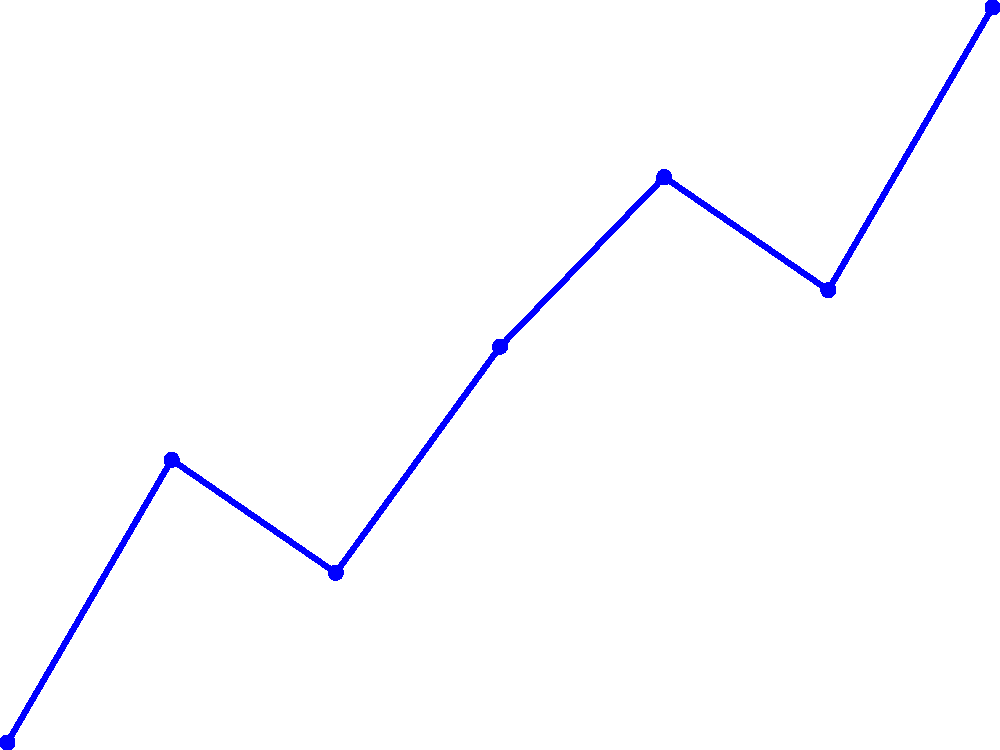Analyze the line graph showing patient medication adherence trends over seven months. What is the overall trend in adherence from January to July, and what is the difference between the highest and lowest adherence percentages? To answer this question, let's follow these steps:

1. Observe the overall trend:
   - Start at January (75%) and end at July (88%)
   - The line generally moves upward, indicating an increasing trend

2. Identify the highest and lowest adherence percentages:
   - Lowest: January at 75%
   - Highest: July at 88%

3. Calculate the difference between the highest and lowest percentages:
   $88\% - 75\% = 13\%$

4. Summarize the findings:
   - The overall trend is increasing from January to July
   - The difference between the highest and lowest percentages is 13%

Therefore, we can conclude that there is an overall increasing trend in medication adherence from January to July, with a 13% difference between the highest and lowest adherence percentages.
Answer: Increasing trend; 13% difference 